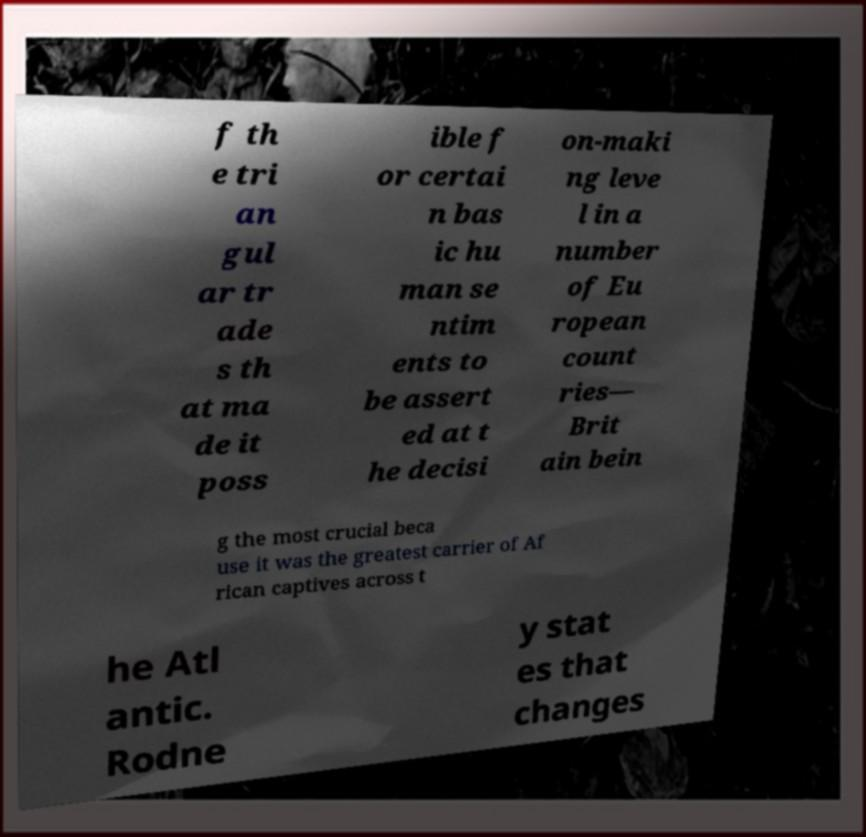There's text embedded in this image that I need extracted. Can you transcribe it verbatim? f th e tri an gul ar tr ade s th at ma de it poss ible f or certai n bas ic hu man se ntim ents to be assert ed at t he decisi on-maki ng leve l in a number of Eu ropean count ries— Brit ain bein g the most crucial beca use it was the greatest carrier of Af rican captives across t he Atl antic. Rodne y stat es that changes 